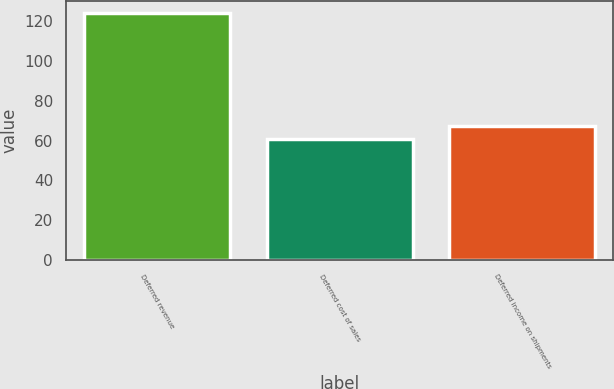Convert chart. <chart><loc_0><loc_0><loc_500><loc_500><bar_chart><fcel>Deferred revenue<fcel>Deferred cost of sales<fcel>Deferred income on shipments<nl><fcel>124<fcel>61<fcel>67.3<nl></chart> 